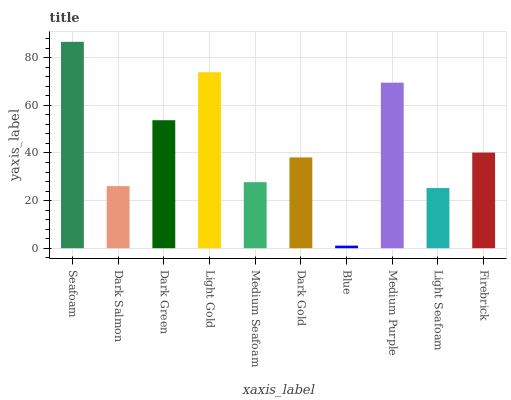Is Blue the minimum?
Answer yes or no. Yes. Is Seafoam the maximum?
Answer yes or no. Yes. Is Dark Salmon the minimum?
Answer yes or no. No. Is Dark Salmon the maximum?
Answer yes or no. No. Is Seafoam greater than Dark Salmon?
Answer yes or no. Yes. Is Dark Salmon less than Seafoam?
Answer yes or no. Yes. Is Dark Salmon greater than Seafoam?
Answer yes or no. No. Is Seafoam less than Dark Salmon?
Answer yes or no. No. Is Firebrick the high median?
Answer yes or no. Yes. Is Dark Gold the low median?
Answer yes or no. Yes. Is Blue the high median?
Answer yes or no. No. Is Medium Purple the low median?
Answer yes or no. No. 